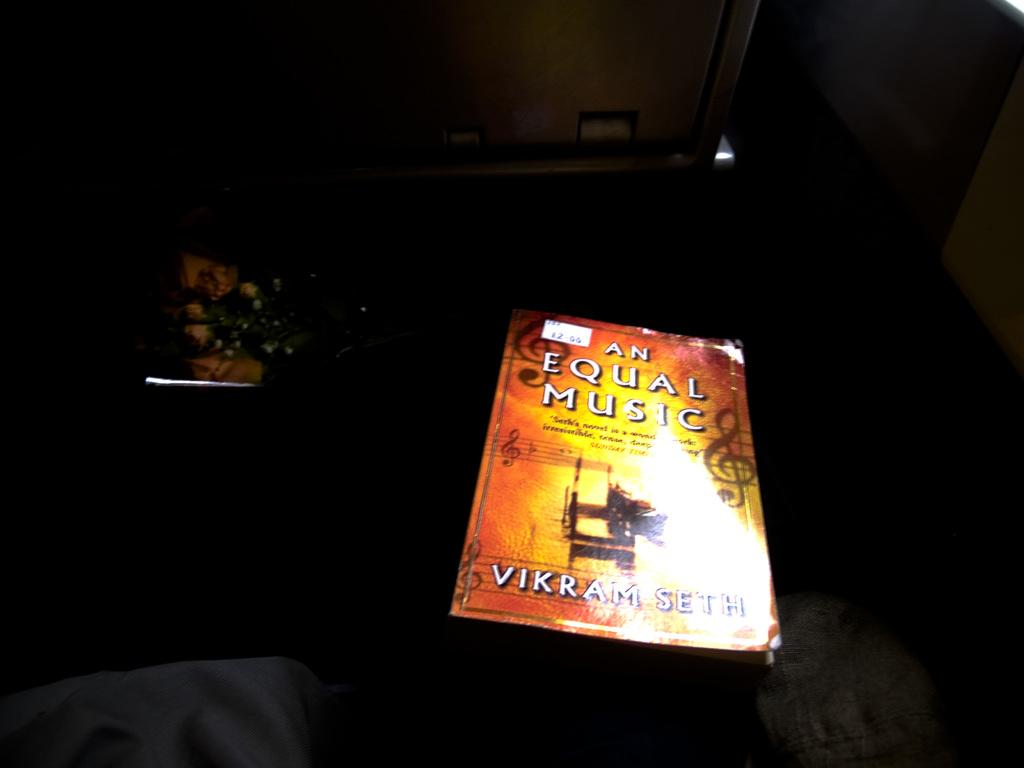<image>
Summarize the visual content of the image. The cover the book An Equal Music with a price sticker 